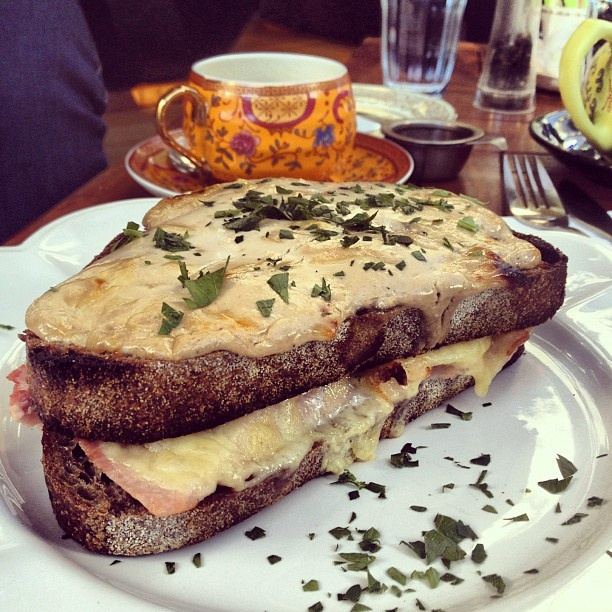Describe the objects in this image and their specific colors. I can see dining table in beige, purple, tan, maroon, and black tones, sandwich in purple, tan, maroon, and black tones, cup in purple, brown, red, orange, and tan tones, people in purple, navy, and maroon tones, and cup in navy, gray, darkgray, black, and purple tones in this image. 